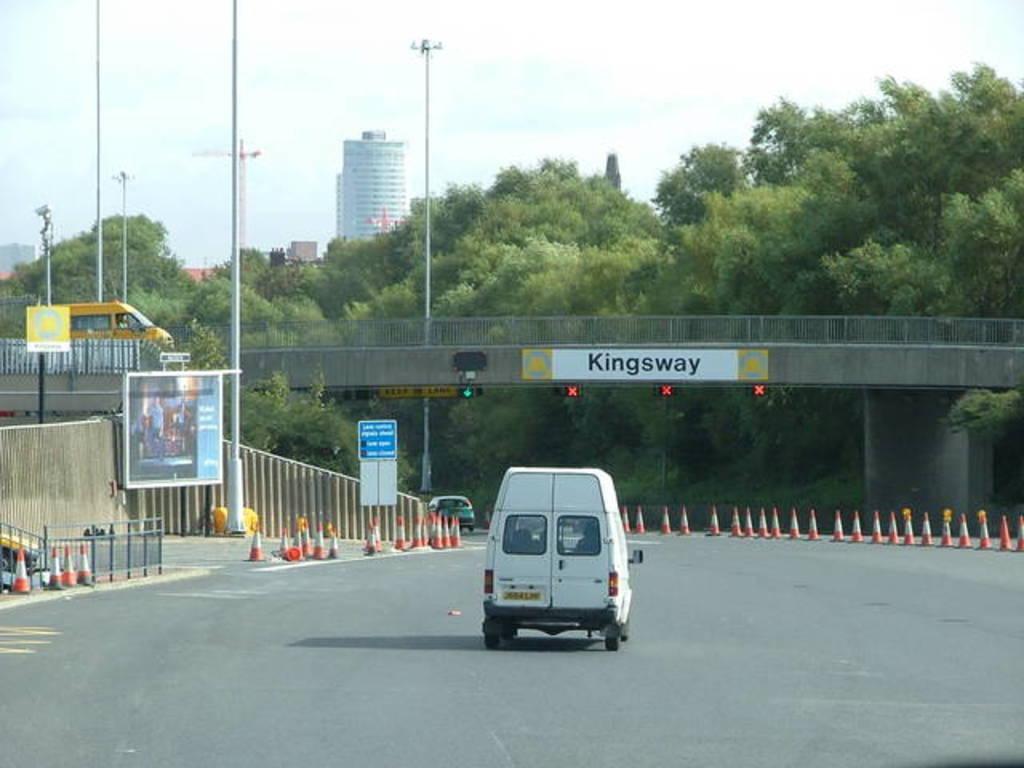Please provide a concise description of this image. In the center of the image we can see vehicle on the road. On the right and left side of the image we can see traffic cones. In the background we can see bridge, trees, buildings, poles, sky and clouds. 